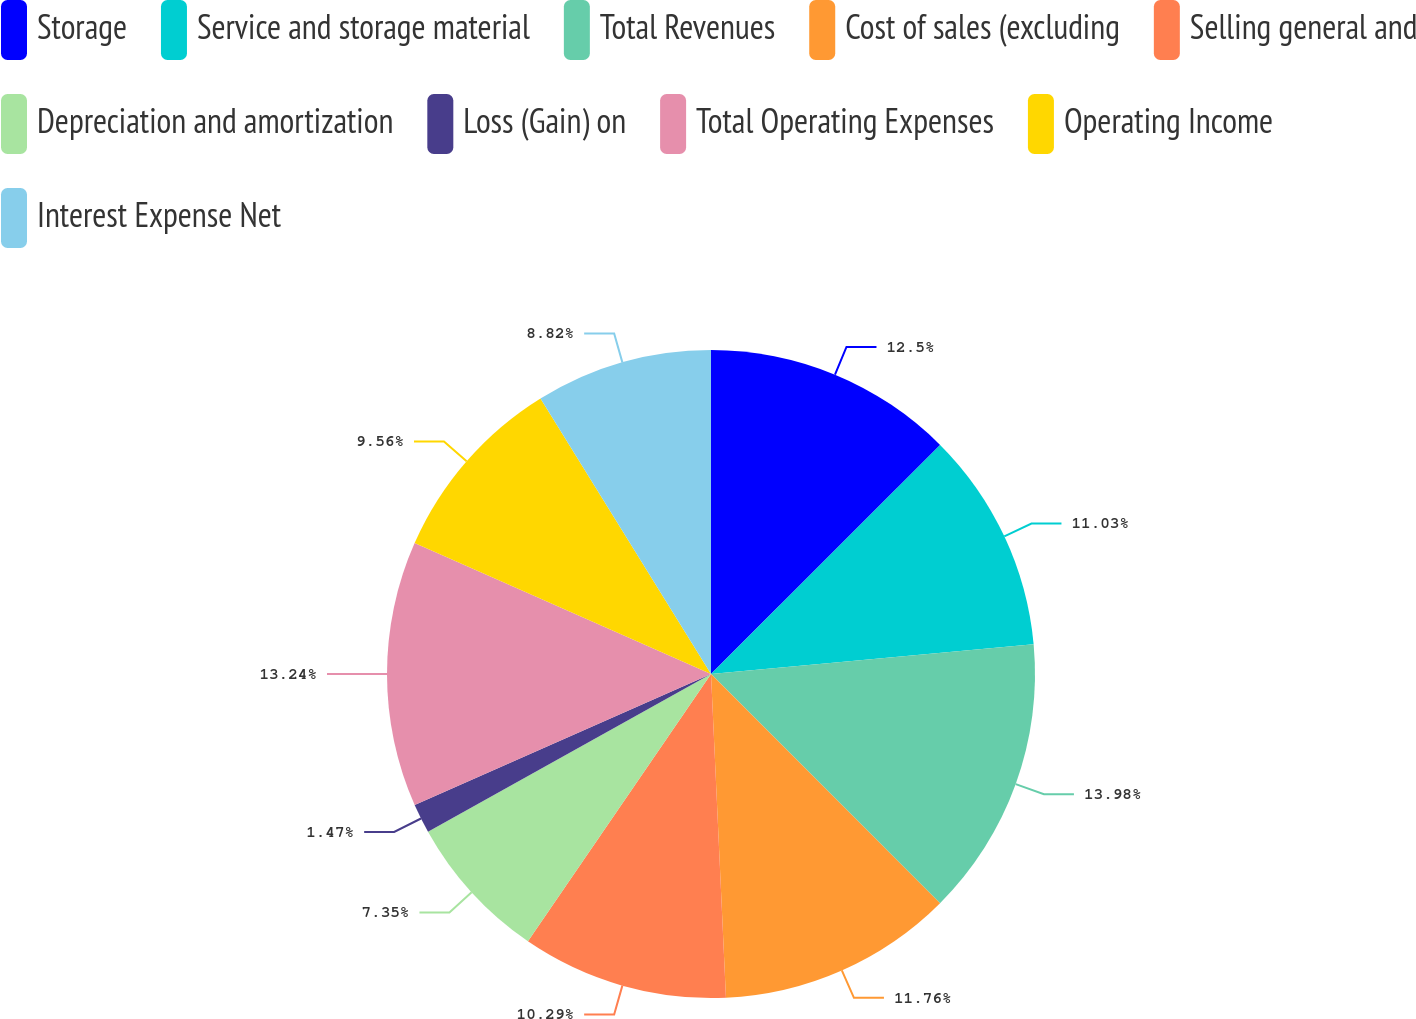<chart> <loc_0><loc_0><loc_500><loc_500><pie_chart><fcel>Storage<fcel>Service and storage material<fcel>Total Revenues<fcel>Cost of sales (excluding<fcel>Selling general and<fcel>Depreciation and amortization<fcel>Loss (Gain) on<fcel>Total Operating Expenses<fcel>Operating Income<fcel>Interest Expense Net<nl><fcel>12.5%<fcel>11.03%<fcel>13.97%<fcel>11.76%<fcel>10.29%<fcel>7.35%<fcel>1.47%<fcel>13.24%<fcel>9.56%<fcel>8.82%<nl></chart> 